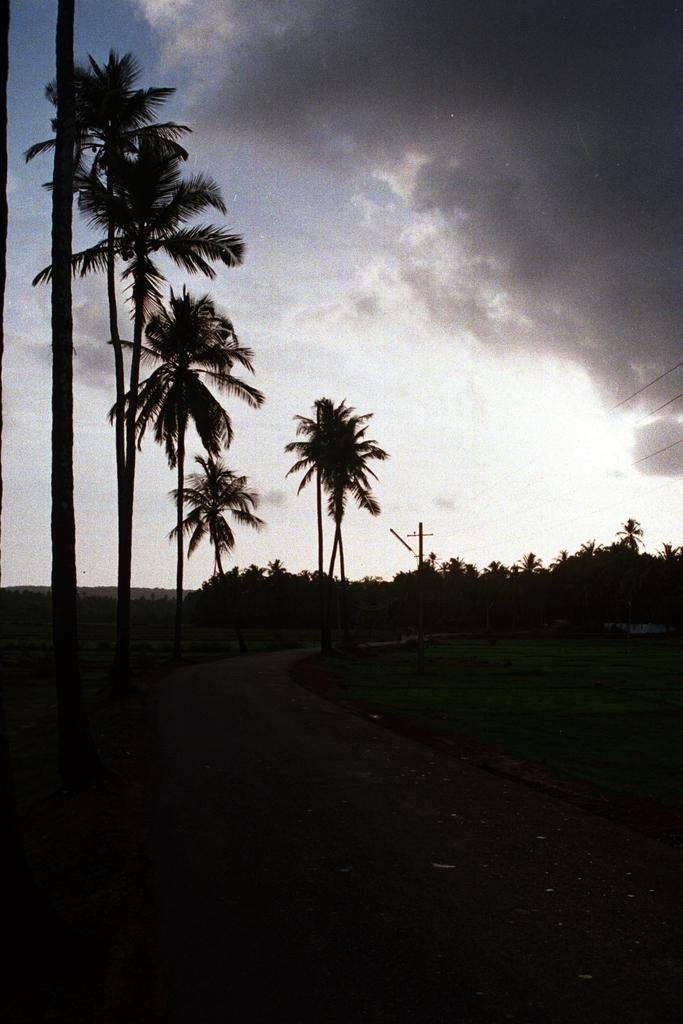What type of vegetation can be seen in the image? There are trees in the image, extending from left to right. What is the condition of the sky in the image? The sky is cloudy in the image. What can be seen at the bottom of the image? There is a dark view at the bottom of the image. What type of sticks can be seen being used in a process by a stranger in the image? There are no sticks, processes, or strangers present in the image. 